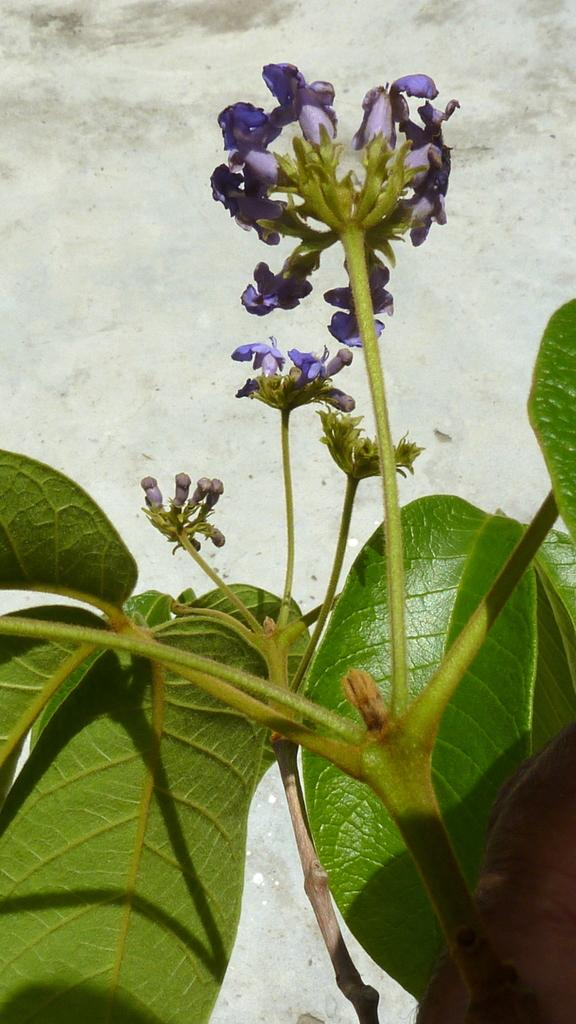What type of plant life is visible in the image? There are flowers and leaves in the image. Can you describe the background of the image? There is a wall in the background of the image. What type of mint can be seen growing on the wall in the image? There is no mint visible in the image; only flowers and leaves are present. 